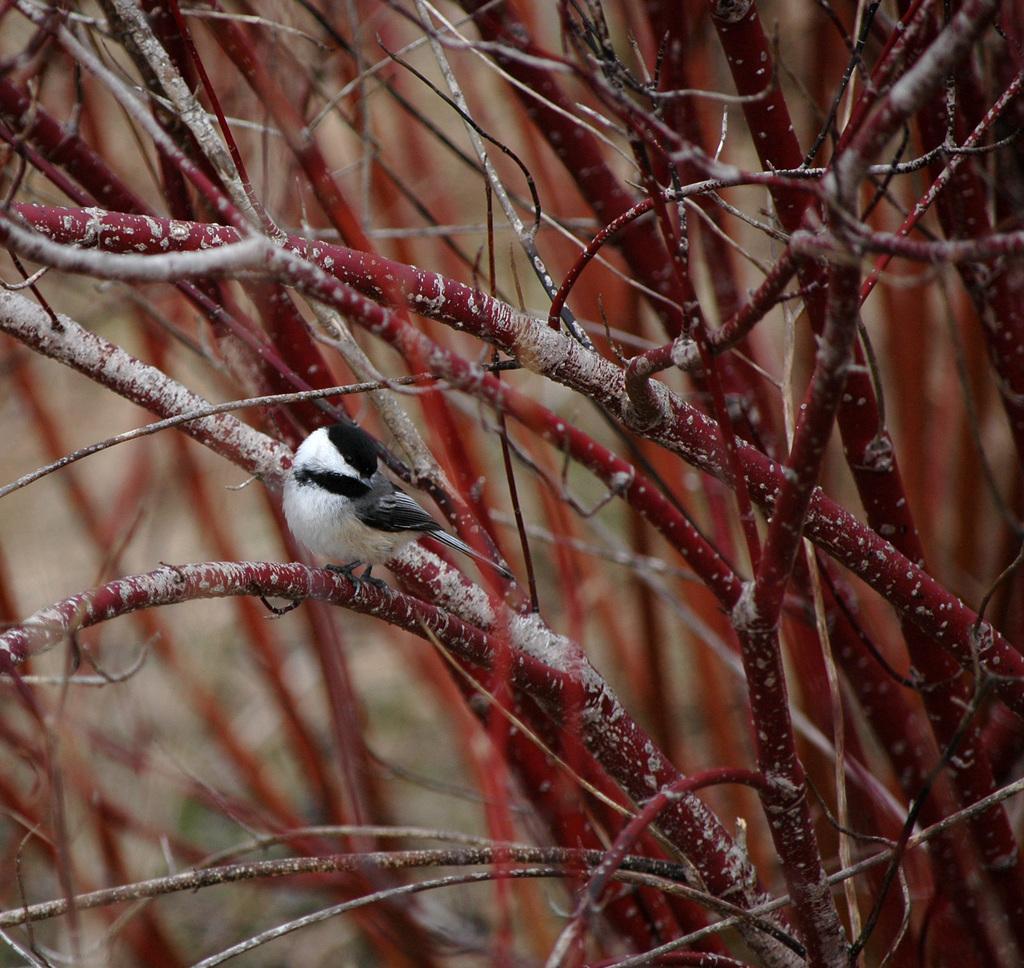Can you describe this image briefly? This image consists of a bird. It is in black and white color. In the background, there are plants and stems. The stems are in red color. 